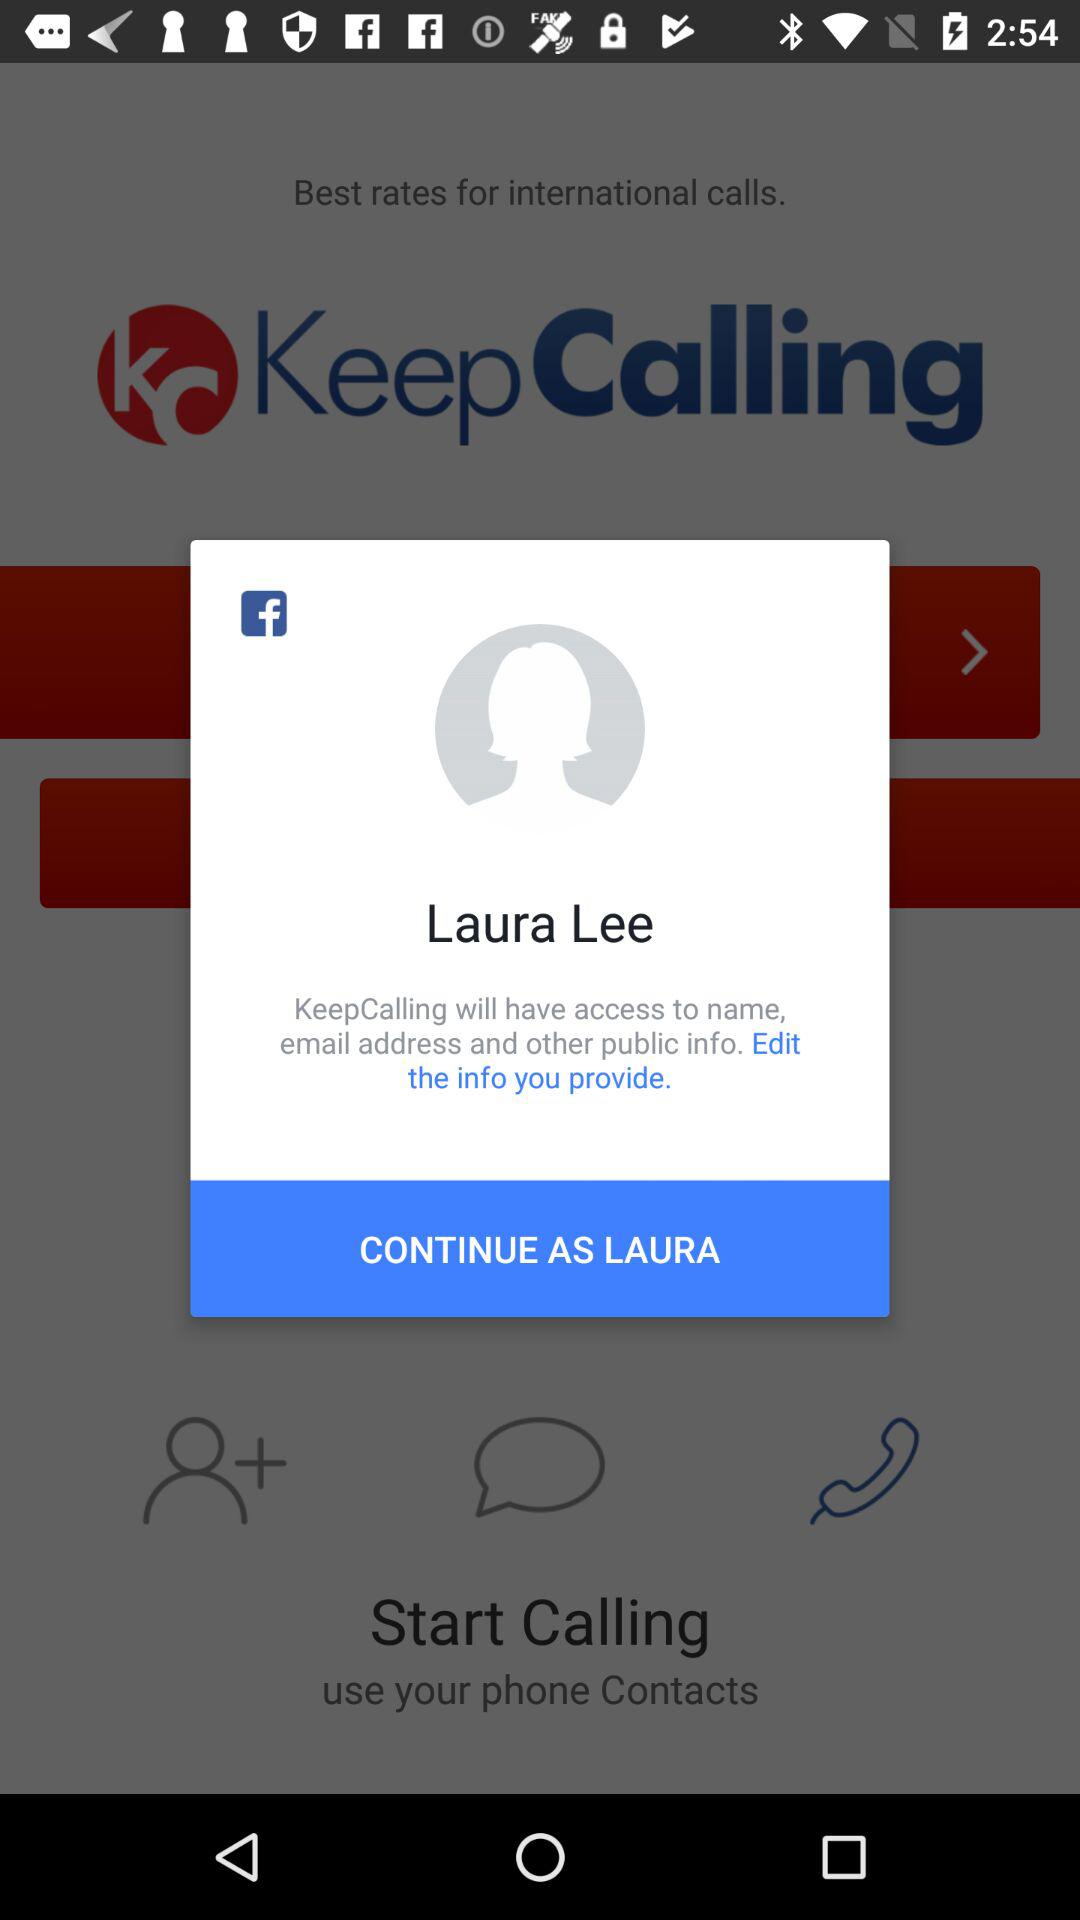What is the name of the user? The name of the user is Laura Lee. 